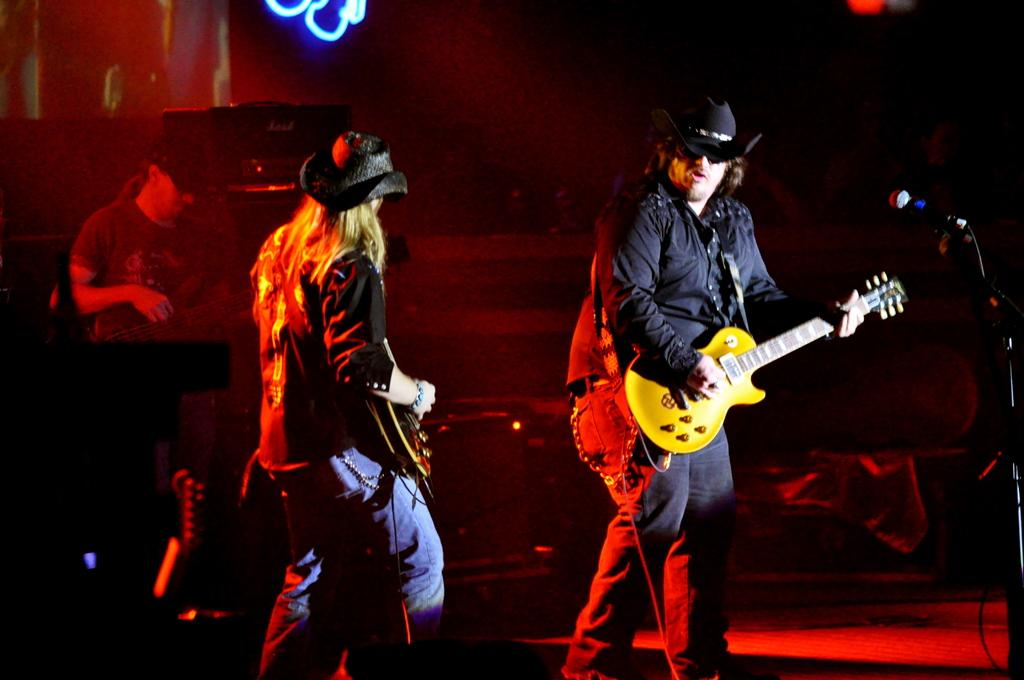What is the man in the image doing? The man in the image is playing the guitar. Can you describe the man's attire in the image? The man is wearing a hat. Is there anyone else in the image besides the man playing the guitar? Yes, there is another person standing in the image. What can be seen at the top of the image? There is a light at the top of the image. What type of competition is the man participating in with his guitar in the image? There is no indication of a competition in the image; the man is simply playing the guitar. Can you tell me how many cups are visible in the image? There are no cups present in the image. 